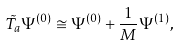<formula> <loc_0><loc_0><loc_500><loc_500>\tilde { T _ { a } } \Psi ^ { ( 0 ) } \cong \Psi ^ { ( 0 ) } + \frac { 1 } { M } \Psi ^ { ( 1 ) } ,</formula> 